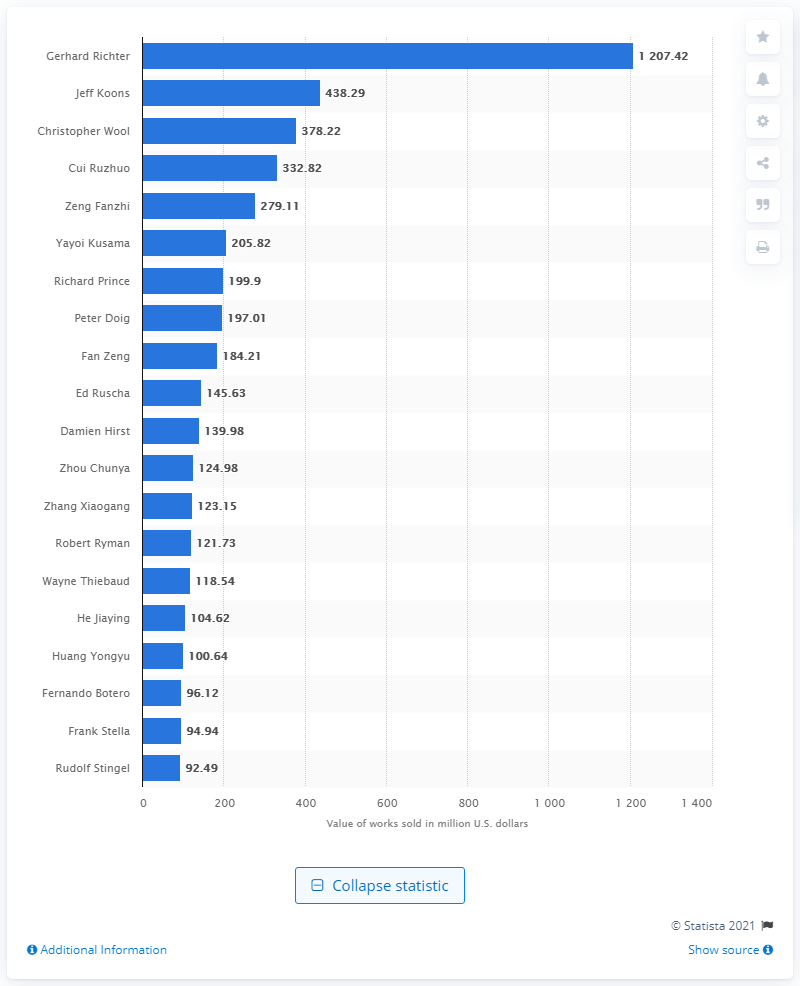Specify some key components in this picture. Gerhard Richter was the most collectible living artist worldwide between 2011 and 2016. 